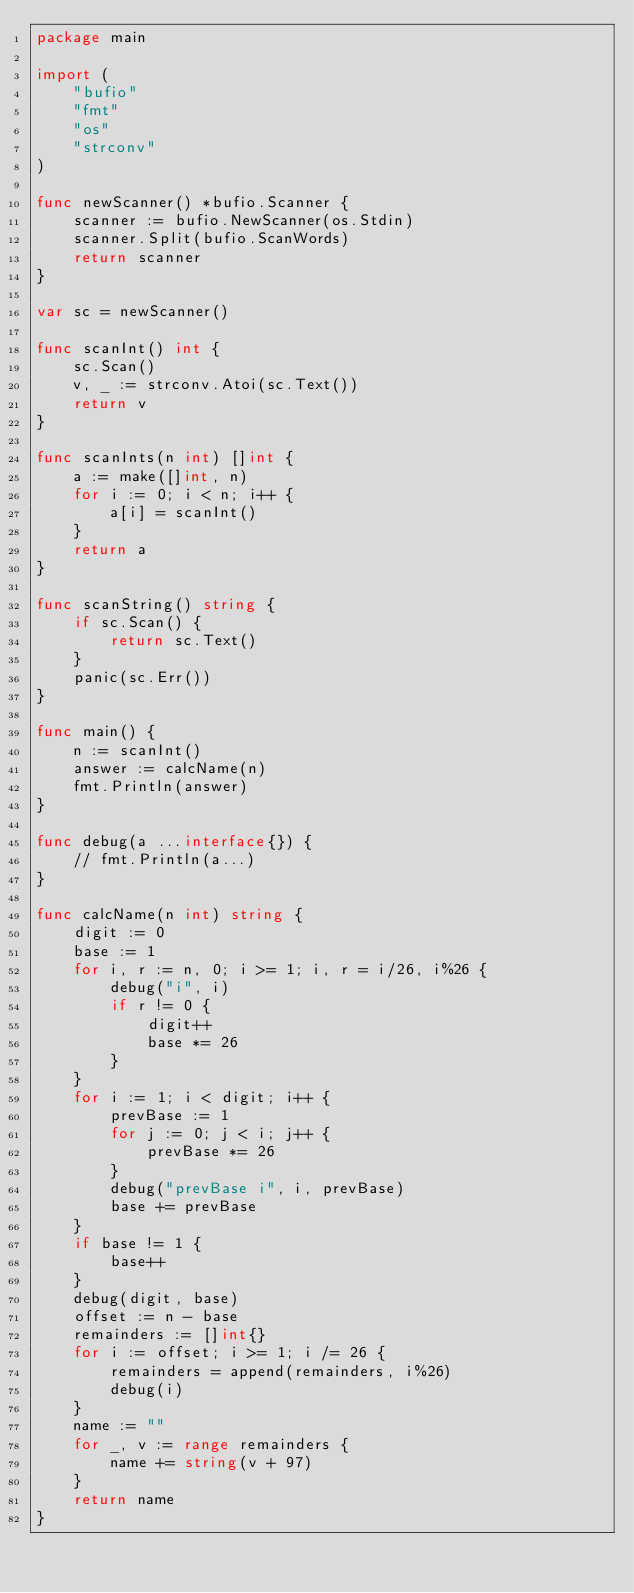<code> <loc_0><loc_0><loc_500><loc_500><_Go_>package main

import (
	"bufio"
	"fmt"
	"os"
	"strconv"
)

func newScanner() *bufio.Scanner {
	scanner := bufio.NewScanner(os.Stdin)
	scanner.Split(bufio.ScanWords)
	return scanner
}

var sc = newScanner()

func scanInt() int {
	sc.Scan()
	v, _ := strconv.Atoi(sc.Text())
	return v
}

func scanInts(n int) []int {
	a := make([]int, n)
	for i := 0; i < n; i++ {
		a[i] = scanInt()
	}
	return a
}

func scanString() string {
	if sc.Scan() {
		return sc.Text()
	}
	panic(sc.Err())
}

func main() {
	n := scanInt()
	answer := calcName(n)
	fmt.Println(answer)
}

func debug(a ...interface{}) {
	// fmt.Println(a...)
}

func calcName(n int) string {
	digit := 0
	base := 1
	for i, r := n, 0; i >= 1; i, r = i/26, i%26 {
		debug("i", i)
		if r != 0 {
			digit++
			base *= 26
		}
	}
	for i := 1; i < digit; i++ {
		prevBase := 1
		for j := 0; j < i; j++ {
			prevBase *= 26
		}
		debug("prevBase i", i, prevBase)
		base += prevBase
	}
	if base != 1 {
		base++
	}
	debug(digit, base)
	offset := n - base
	remainders := []int{}
	for i := offset; i >= 1; i /= 26 {
		remainders = append(remainders, i%26)
		debug(i)
	}
	name := ""
	for _, v := range remainders {
		name += string(v + 97)
	}
	return name
}
</code> 